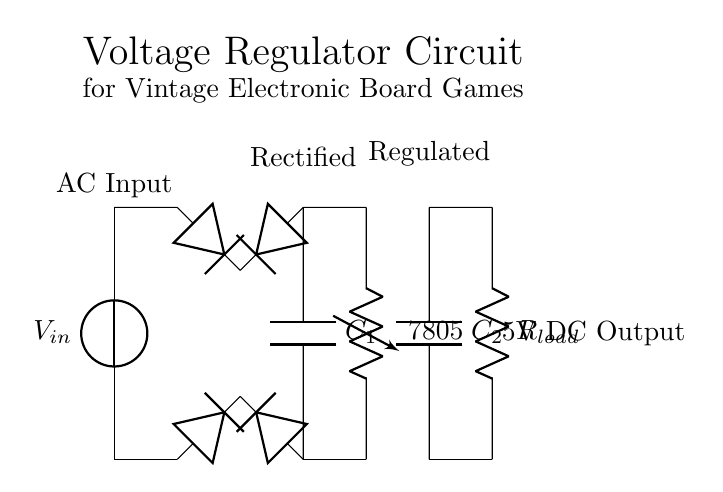What is the input type for this circuit? The circuit begins with a component labeled as an AC voltage source, which indicates that the circuit is powered by an alternating current source.
Answer: AC What is the role of the capacitor labeled C1? C1 is connected between the output of the bridge rectifier and ground, which signifies that it is used for smoothing the rectified voltage, helping to reduce fluctuations and provide a stable DC voltage.
Answer: Smoothing What is the output voltage of this regulator? The voltage regulator labeled as a 7805 is specifically designed to output a constant voltage of 5V DC, making it suitable for low-voltage applications.
Answer: 5V How many diodes are present in the rectifier section? The circuit diagram indicates four diodes in total are used as part of the bridge rectifier to convert AC to DC.
Answer: Four What would happen if C2 is omitted in this circuit? C2 acts as an output capacitor which helps stabilize the output voltage, reducing ripple, and ensuring smooth operation; omitting it would likely lead to voltage fluctuations under load.
Answer: Voltage fluctuations What type of load does R_load represent in the circuit? R_load, depicted in the output section of the circuit, represents the load resistance that the circuit is designed to power, simulating the load of vintage electronic board games.
Answer: Load resistance 